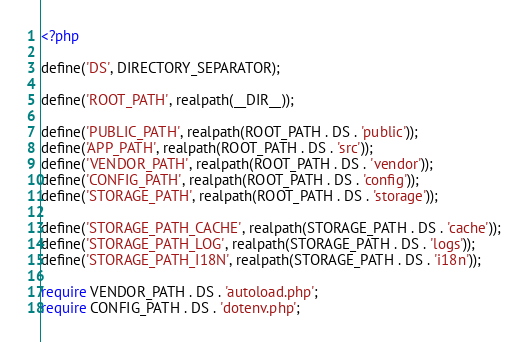<code> <loc_0><loc_0><loc_500><loc_500><_PHP_><?php

define('DS', DIRECTORY_SEPARATOR);

define('ROOT_PATH', realpath(__DIR__));

define('PUBLIC_PATH', realpath(ROOT_PATH . DS . 'public'));
define('APP_PATH', realpath(ROOT_PATH . DS . 'src'));
define('VENDOR_PATH', realpath(ROOT_PATH . DS . 'vendor'));
define('CONFIG_PATH', realpath(ROOT_PATH . DS . 'config'));
define('STORAGE_PATH', realpath(ROOT_PATH . DS . 'storage'));

define('STORAGE_PATH_CACHE', realpath(STORAGE_PATH . DS . 'cache'));
define('STORAGE_PATH_LOG', realpath(STORAGE_PATH . DS . 'logs'));
define('STORAGE_PATH_I18N', realpath(STORAGE_PATH . DS . 'i18n'));

require VENDOR_PATH . DS . 'autoload.php';
require CONFIG_PATH . DS . 'dotenv.php';
</code> 